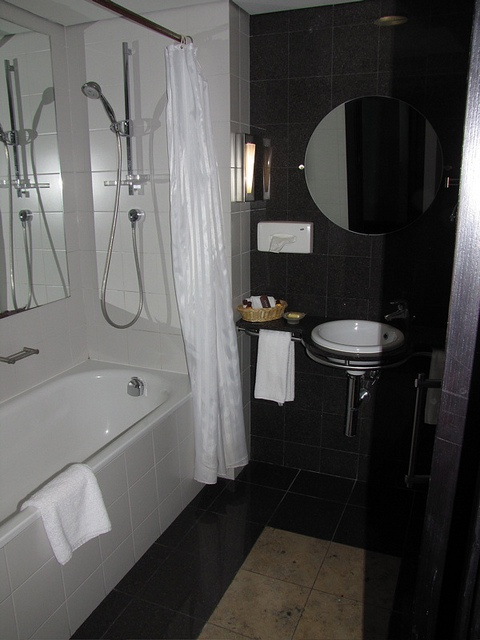Describe the objects in this image and their specific colors. I can see a sink in gray, darkgray, and black tones in this image. 